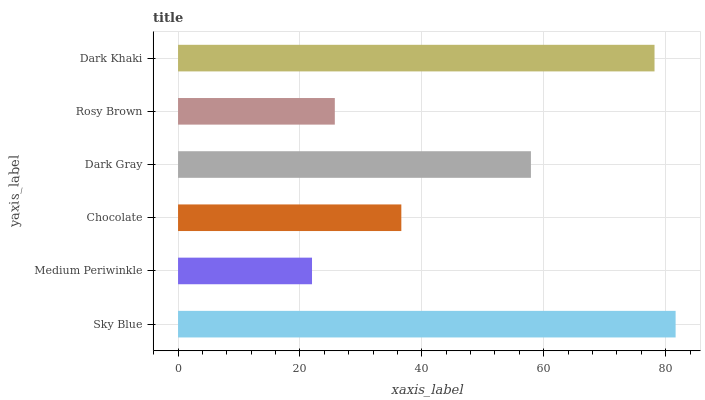Is Medium Periwinkle the minimum?
Answer yes or no. Yes. Is Sky Blue the maximum?
Answer yes or no. Yes. Is Chocolate the minimum?
Answer yes or no. No. Is Chocolate the maximum?
Answer yes or no. No. Is Chocolate greater than Medium Periwinkle?
Answer yes or no. Yes. Is Medium Periwinkle less than Chocolate?
Answer yes or no. Yes. Is Medium Periwinkle greater than Chocolate?
Answer yes or no. No. Is Chocolate less than Medium Periwinkle?
Answer yes or no. No. Is Dark Gray the high median?
Answer yes or no. Yes. Is Chocolate the low median?
Answer yes or no. Yes. Is Dark Khaki the high median?
Answer yes or no. No. Is Sky Blue the low median?
Answer yes or no. No. 